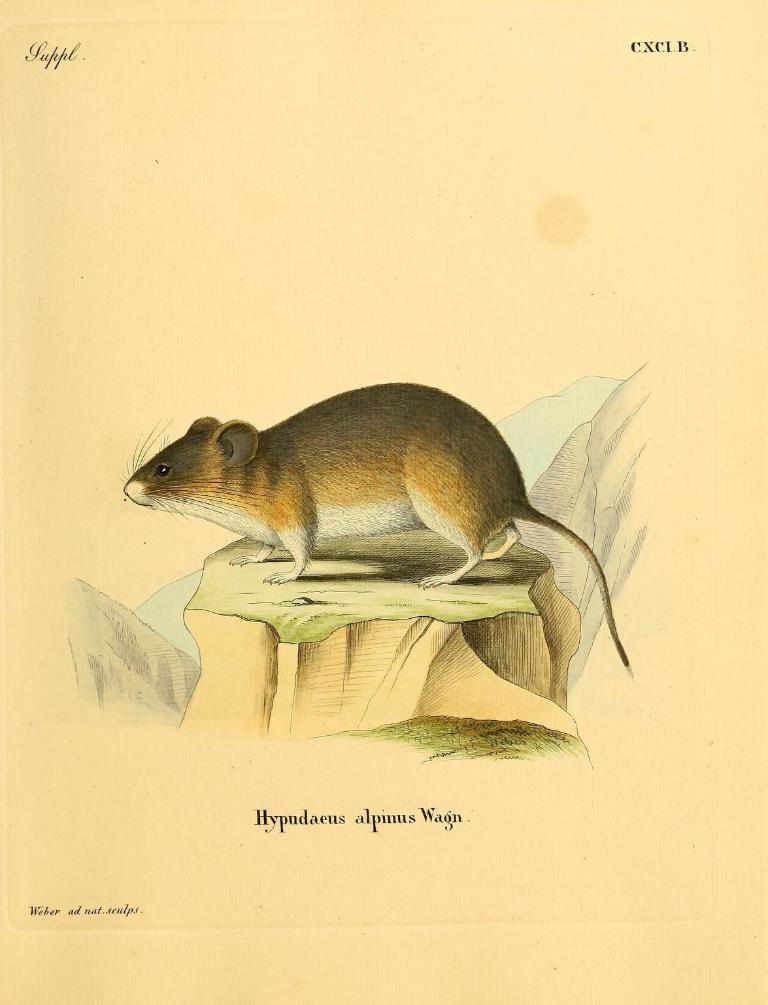Can you describe this image briefly? In this image I can see the drawing of a rat which is brown, black and cream in color is on the green and brown colored object. I can see the cream colored background. 